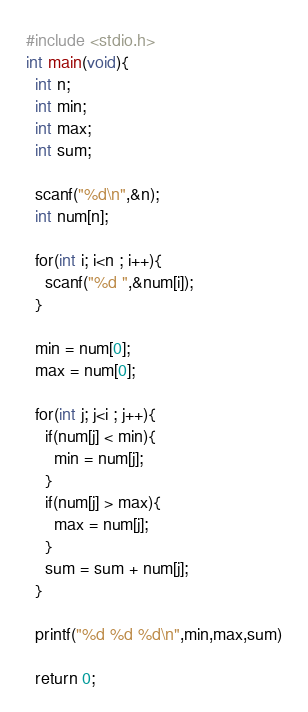<code> <loc_0><loc_0><loc_500><loc_500><_C_>#include <stdio.h>
int main(void){
  int n;
  int min;
  int max;
  int sum;

  scanf("%d\n",&n);
  int num[n];

  for(int i; i<n ; i++){
    scanf("%d ",&num[i]);
  }

  min = num[0];
  max = num[0];

  for(int j; j<i ; j++){
    if(num[j] < min){
      min = num[j];
    }
    if(num[j] > max){
      max = num[j];
    }
    sum = sum + num[j];
  }

  printf("%d %d %d\n",min,max,sum)

  return 0;
</code> 